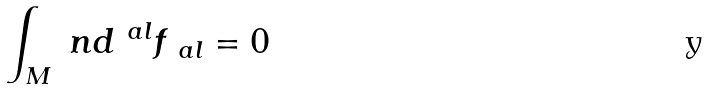<formula> <loc_0><loc_0><loc_500><loc_500>\int _ { M } \ n d ^ { \ a l } f _ { \ a l } = 0</formula> 